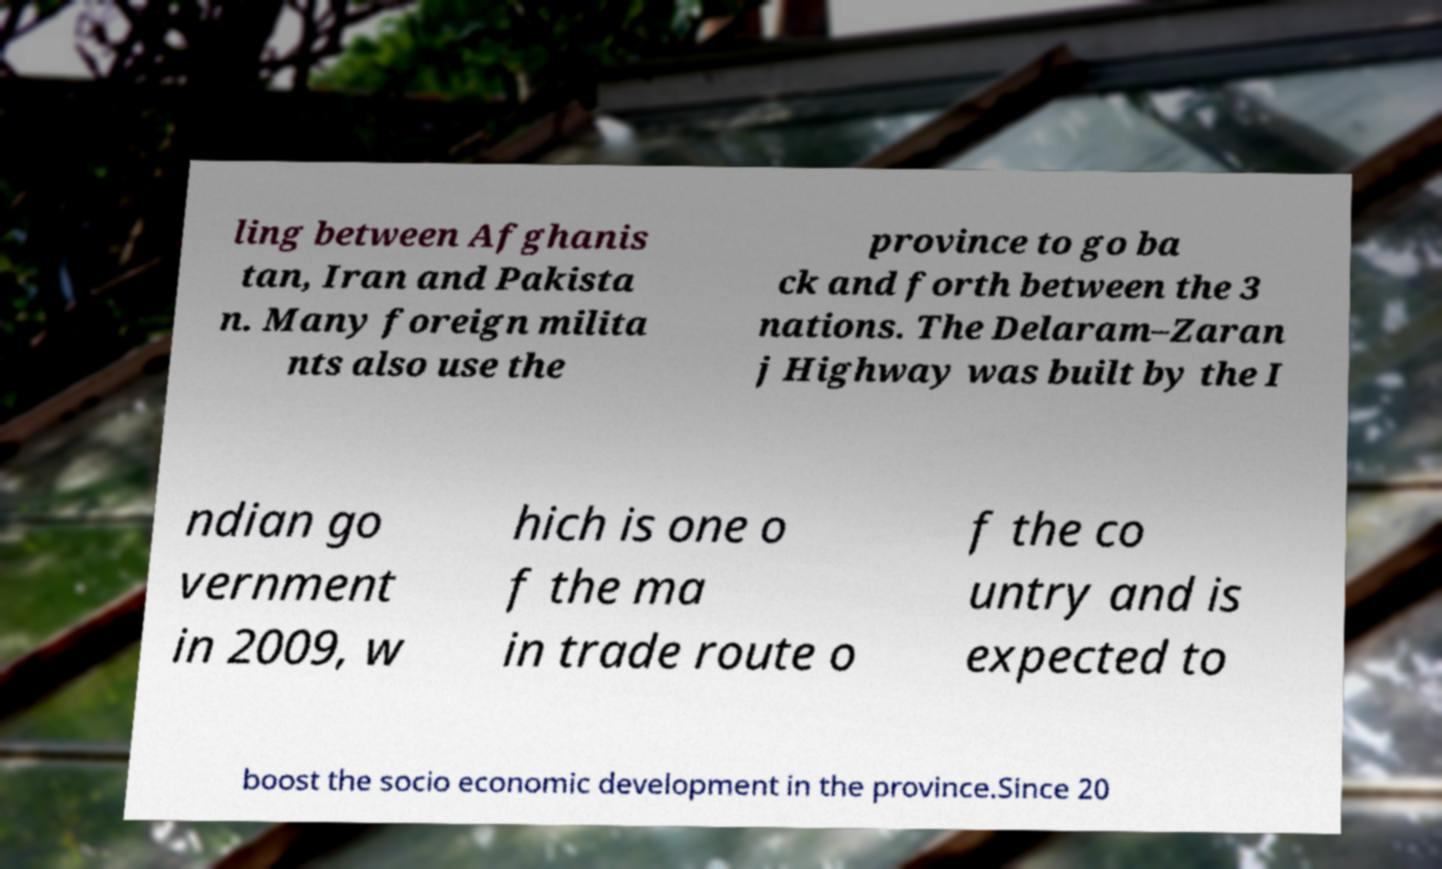Can you accurately transcribe the text from the provided image for me? ling between Afghanis tan, Iran and Pakista n. Many foreign milita nts also use the province to go ba ck and forth between the 3 nations. The Delaram–Zaran j Highway was built by the I ndian go vernment in 2009, w hich is one o f the ma in trade route o f the co untry and is expected to boost the socio economic development in the province.Since 20 